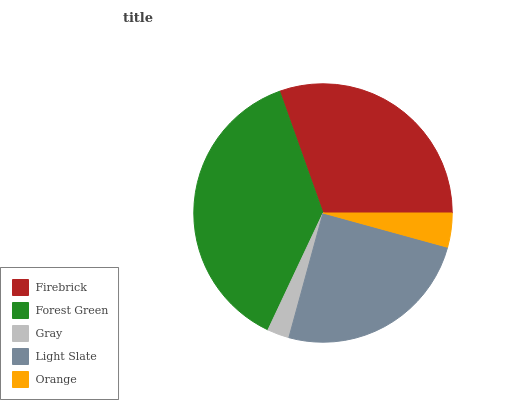Is Gray the minimum?
Answer yes or no. Yes. Is Forest Green the maximum?
Answer yes or no. Yes. Is Forest Green the minimum?
Answer yes or no. No. Is Gray the maximum?
Answer yes or no. No. Is Forest Green greater than Gray?
Answer yes or no. Yes. Is Gray less than Forest Green?
Answer yes or no. Yes. Is Gray greater than Forest Green?
Answer yes or no. No. Is Forest Green less than Gray?
Answer yes or no. No. Is Light Slate the high median?
Answer yes or no. Yes. Is Light Slate the low median?
Answer yes or no. Yes. Is Gray the high median?
Answer yes or no. No. Is Orange the low median?
Answer yes or no. No. 